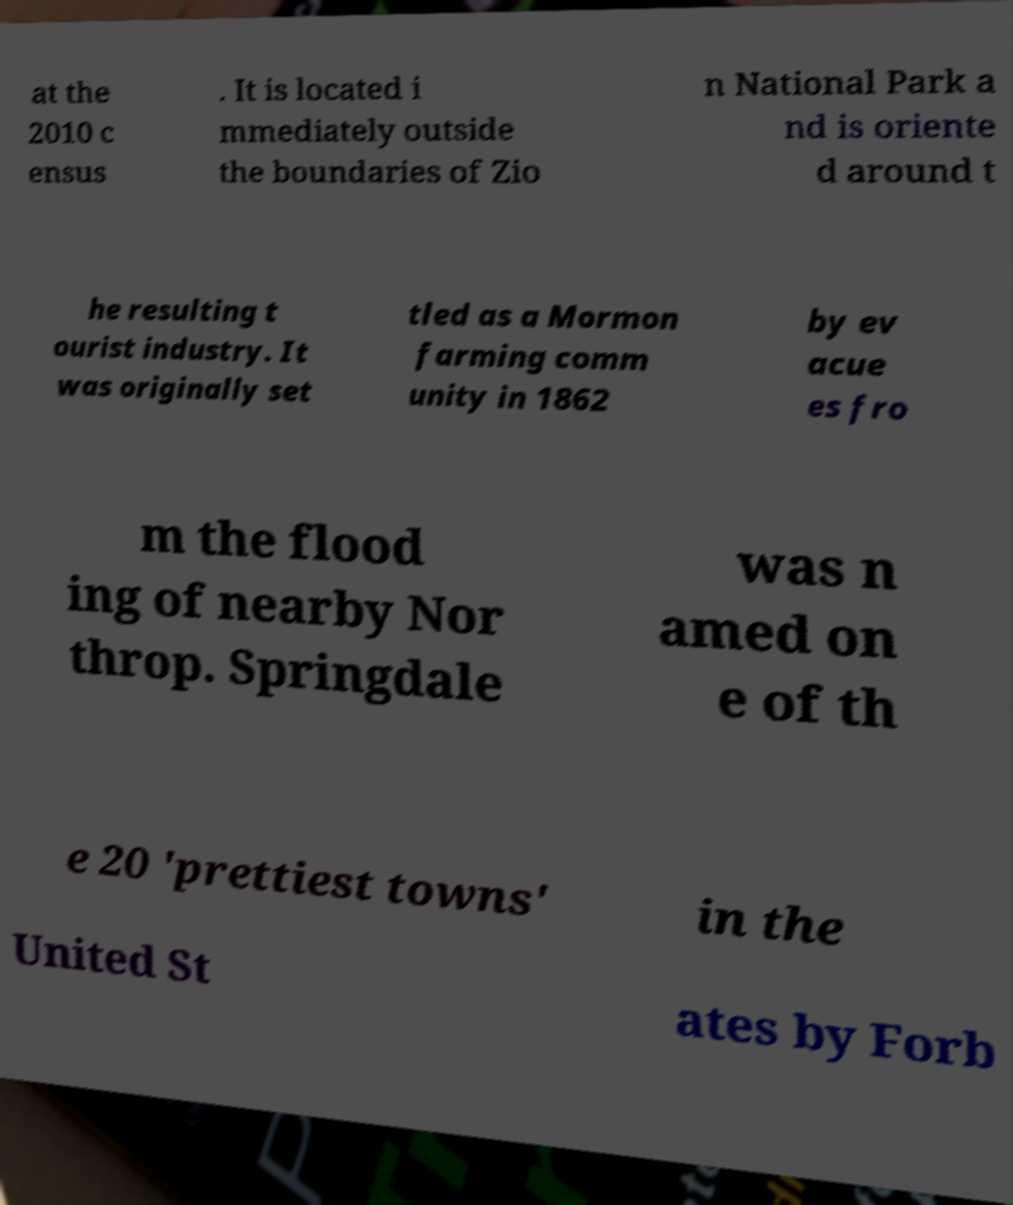Please read and relay the text visible in this image. What does it say? at the 2010 c ensus . It is located i mmediately outside the boundaries of Zio n National Park a nd is oriente d around t he resulting t ourist industry. It was originally set tled as a Mormon farming comm unity in 1862 by ev acue es fro m the flood ing of nearby Nor throp. Springdale was n amed on e of th e 20 'prettiest towns' in the United St ates by Forb 